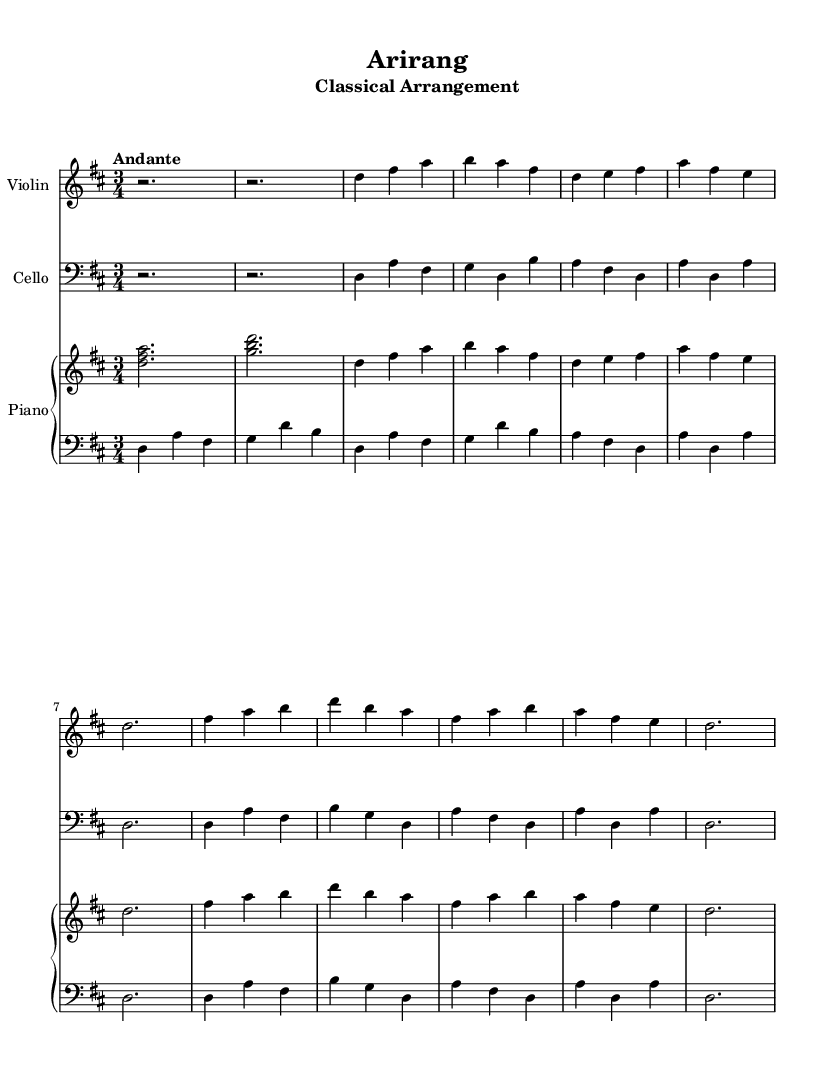What is the key signature of this piece? The key signature is found at the beginning of the sheet music. It indicates D major, which has two sharps (F sharp and C sharp).
Answer: D major What is the time signature of this arrangement? The time signature is located at the beginning of the music score, indicated as 3/4, which means there are three beats in a measure and the quarter note gets one beat.
Answer: 3/4 What tempo marking is used in this composition? The tempo marking appears at the beginning of the score and shows "Andante," which indicates a moderate walking speed for the piece.
Answer: Andante How many themes are presented in this arrangement? The sheet music indicates two main themes (Theme A and Theme B) are labeled in the music, each contributing to the overall structure.
Answer: Two What instrument plays the highest pitch in the introduction? By comparing the instruments and their ranges in the introduction, the violin's parts are higher than the cello and piano parts, making it the highest-pitched instrument.
Answer: Violin Which theme begins with a D note? By examining the musical notation, Theme A starts with the note D and is clearly labeled in the arrangement, confirming it.
Answer: Theme A What is the relation between the violin and piano in this arrangement? Analyzing the parts, the violin plays a melody that is harmonized with the piano, which provides both harmonic support and counterpoint to the violin's lines, showcasing a typical classical piano accompaniment style.
Answer: Harmonized 